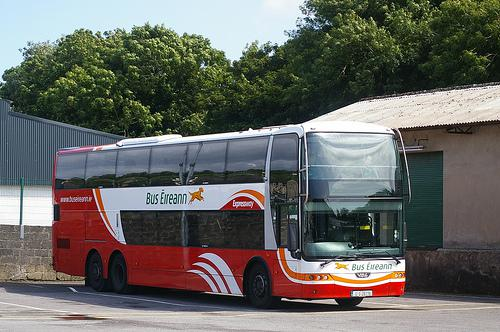Question: what vehicle is in the picture?
Choices:
A. Car.
B. Truck.
C. Bus.
D. Motorcycle.
Answer with the letter. Answer: C Question: where is the bus parked?
Choices:
A. On the street.
B. In a driveway.
C. Parking lot.
D. In front of a school.
Answer with the letter. Answer: C 